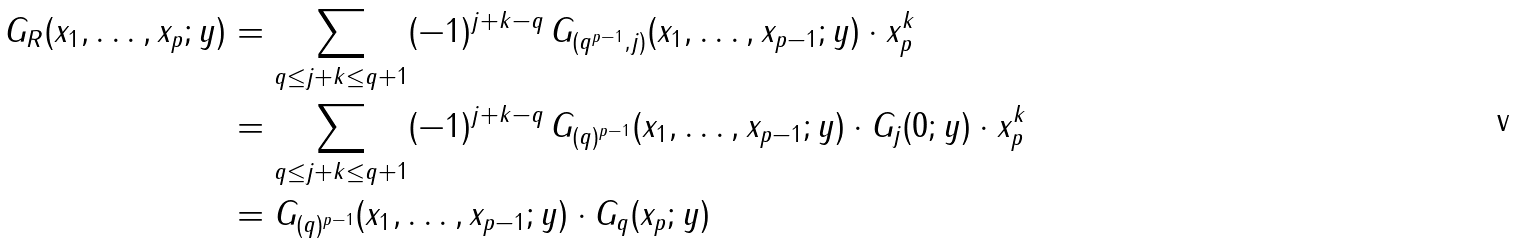<formula> <loc_0><loc_0><loc_500><loc_500>G _ { R } ( x _ { 1 } , \dots , x _ { p } ; y ) & = \sum _ { q \leq j + k \leq q + 1 } ( - 1 ) ^ { j + k - q } \, G _ { ( q ^ { p - 1 } , j ) } ( x _ { 1 } , \dots , x _ { p - 1 } ; y ) \cdot x _ { p } ^ { k } \\ & = \sum _ { q \leq j + k \leq q + 1 } ( - 1 ) ^ { j + k - q } \, G _ { ( q ) ^ { p - 1 } } ( x _ { 1 } , \dots , x _ { p - 1 } ; y ) \cdot G _ { j } ( 0 ; y ) \cdot x _ { p } ^ { k } \\ & = G _ { ( q ) ^ { p - 1 } } ( x _ { 1 } , \dots , x _ { p - 1 } ; y ) \cdot G _ { q } ( x _ { p } ; y )</formula> 